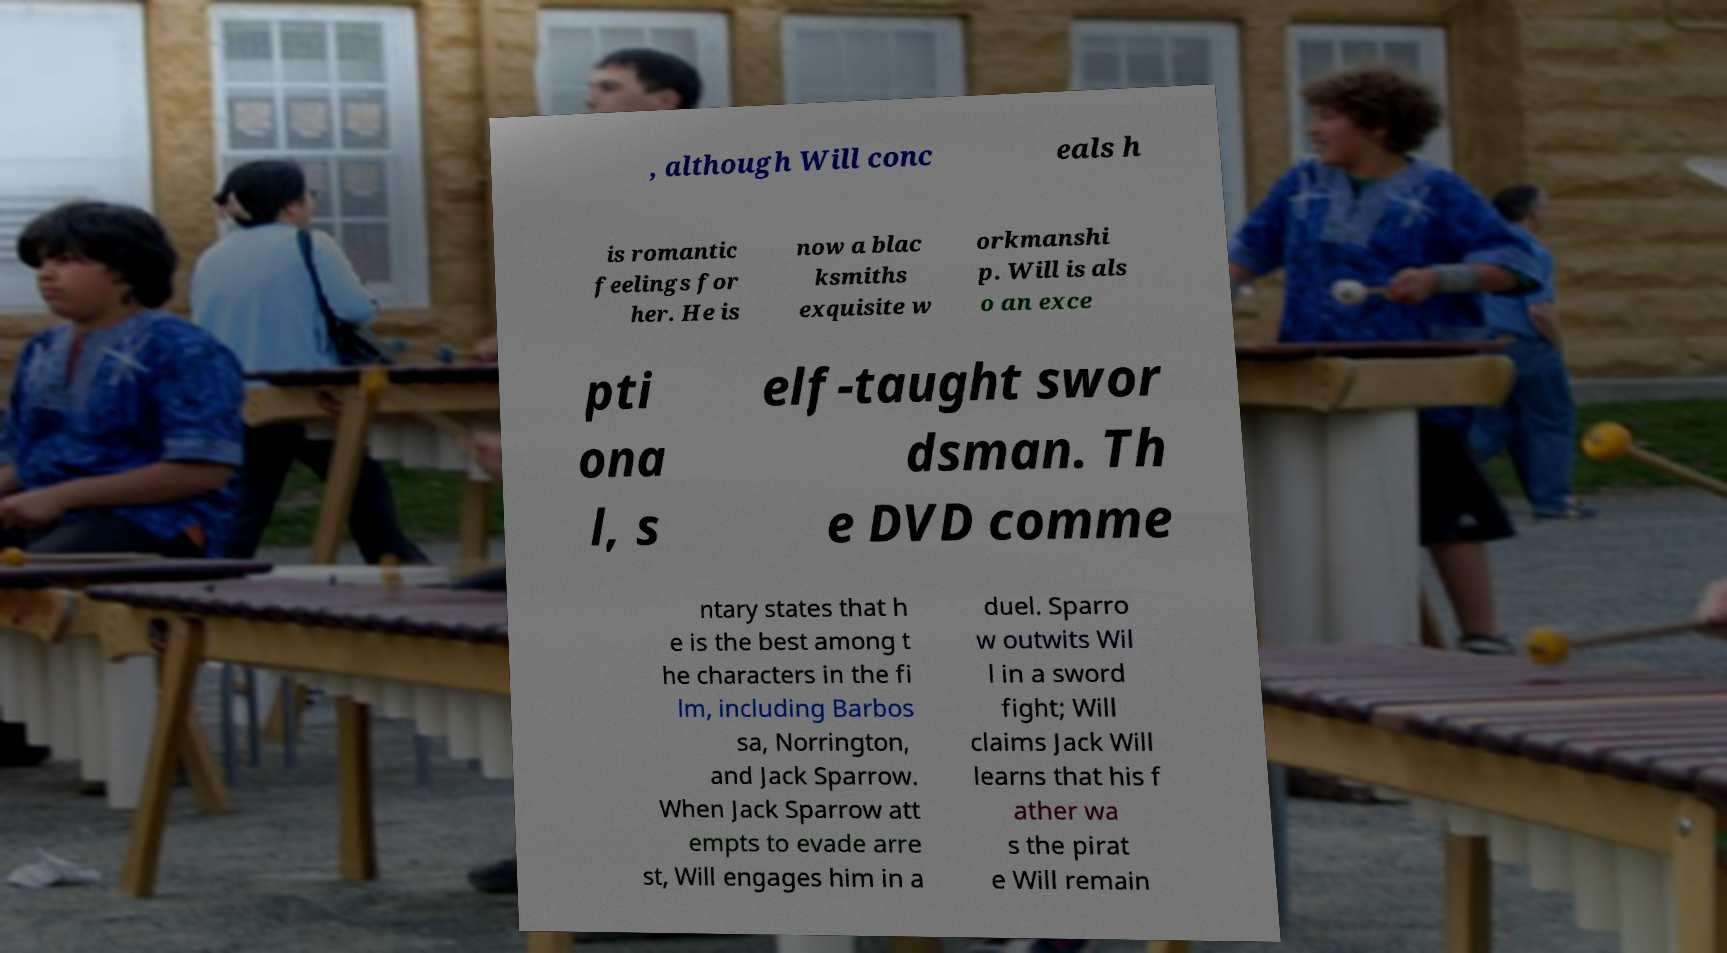What messages or text are displayed in this image? I need them in a readable, typed format. , although Will conc eals h is romantic feelings for her. He is now a blac ksmiths exquisite w orkmanshi p. Will is als o an exce pti ona l, s elf-taught swor dsman. Th e DVD comme ntary states that h e is the best among t he characters in the fi lm, including Barbos sa, Norrington, and Jack Sparrow. When Jack Sparrow att empts to evade arre st, Will engages him in a duel. Sparro w outwits Wil l in a sword fight; Will claims Jack Will learns that his f ather wa s the pirat e Will remain 